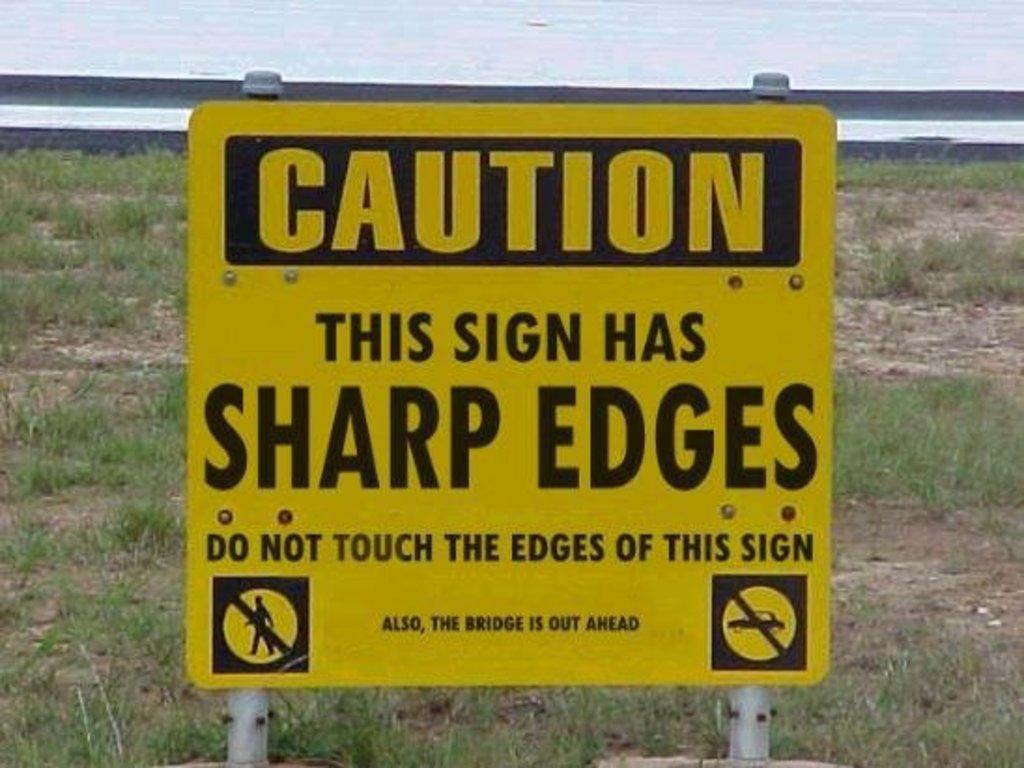<image>
Relay a brief, clear account of the picture shown. a sharp edges sign on the grass under it 